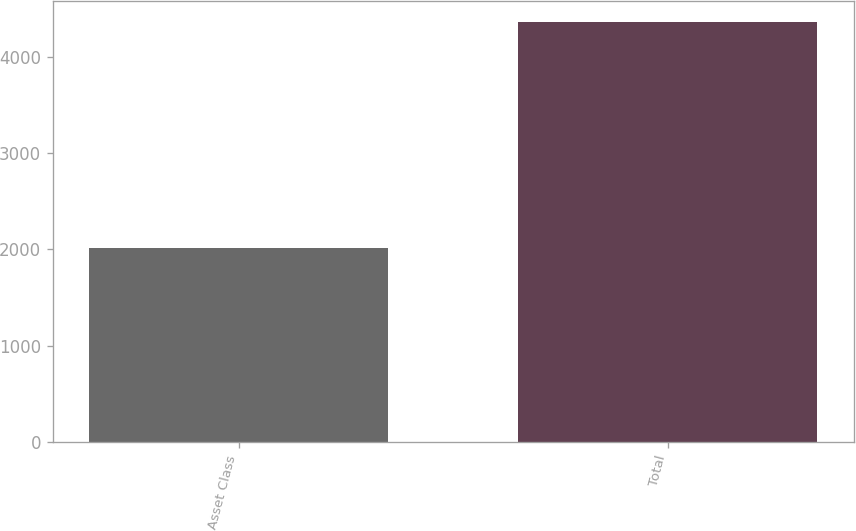<chart> <loc_0><loc_0><loc_500><loc_500><bar_chart><fcel>Asset Class<fcel>Total<nl><fcel>2014<fcel>4367<nl></chart> 